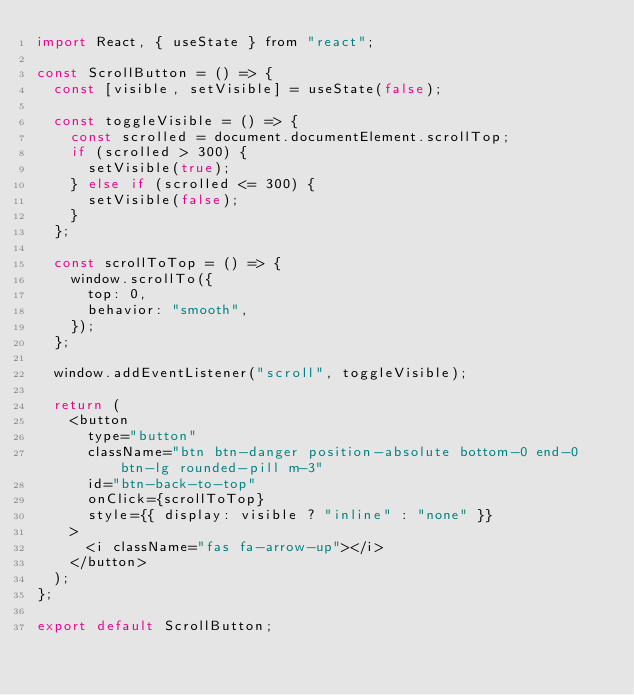Convert code to text. <code><loc_0><loc_0><loc_500><loc_500><_JavaScript_>import React, { useState } from "react";

const ScrollButton = () => {
  const [visible, setVisible] = useState(false);

  const toggleVisible = () => {
    const scrolled = document.documentElement.scrollTop;
    if (scrolled > 300) {
      setVisible(true);
    } else if (scrolled <= 300) {
      setVisible(false);
    }
  };

  const scrollToTop = () => {
    window.scrollTo({
      top: 0,
      behavior: "smooth",
    });
  };

  window.addEventListener("scroll", toggleVisible);

  return (
    <button
      type="button"
      className="btn btn-danger position-absolute bottom-0 end-0 btn-lg rounded-pill m-3"
      id="btn-back-to-top"
      onClick={scrollToTop}
      style={{ display: visible ? "inline" : "none" }}
    >
      <i className="fas fa-arrow-up"></i>
    </button>
  );
};

export default ScrollButton;
</code> 